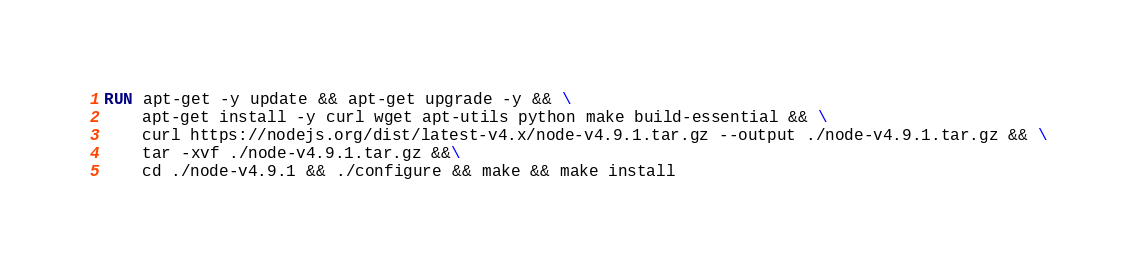<code> <loc_0><loc_0><loc_500><loc_500><_Dockerfile_>RUN apt-get -y update && apt-get upgrade -y && \
    apt-get install -y curl wget apt-utils python make build-essential && \
    curl https://nodejs.org/dist/latest-v4.x/node-v4.9.1.tar.gz --output ./node-v4.9.1.tar.gz && \
    tar -xvf ./node-v4.9.1.tar.gz &&\
    cd ./node-v4.9.1 && ./configure && make && make install</code> 